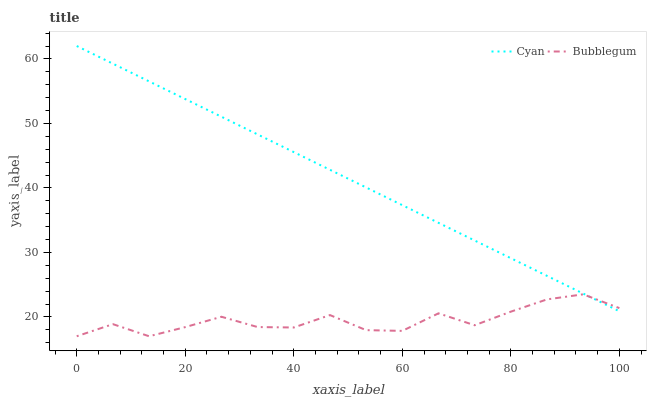Does Bubblegum have the minimum area under the curve?
Answer yes or no. Yes. Does Cyan have the maximum area under the curve?
Answer yes or no. Yes. Does Bubblegum have the maximum area under the curve?
Answer yes or no. No. Is Cyan the smoothest?
Answer yes or no. Yes. Is Bubblegum the roughest?
Answer yes or no. Yes. Is Bubblegum the smoothest?
Answer yes or no. No. Does Bubblegum have the lowest value?
Answer yes or no. Yes. Does Cyan have the highest value?
Answer yes or no. Yes. Does Bubblegum have the highest value?
Answer yes or no. No. Does Cyan intersect Bubblegum?
Answer yes or no. Yes. Is Cyan less than Bubblegum?
Answer yes or no. No. Is Cyan greater than Bubblegum?
Answer yes or no. No. 